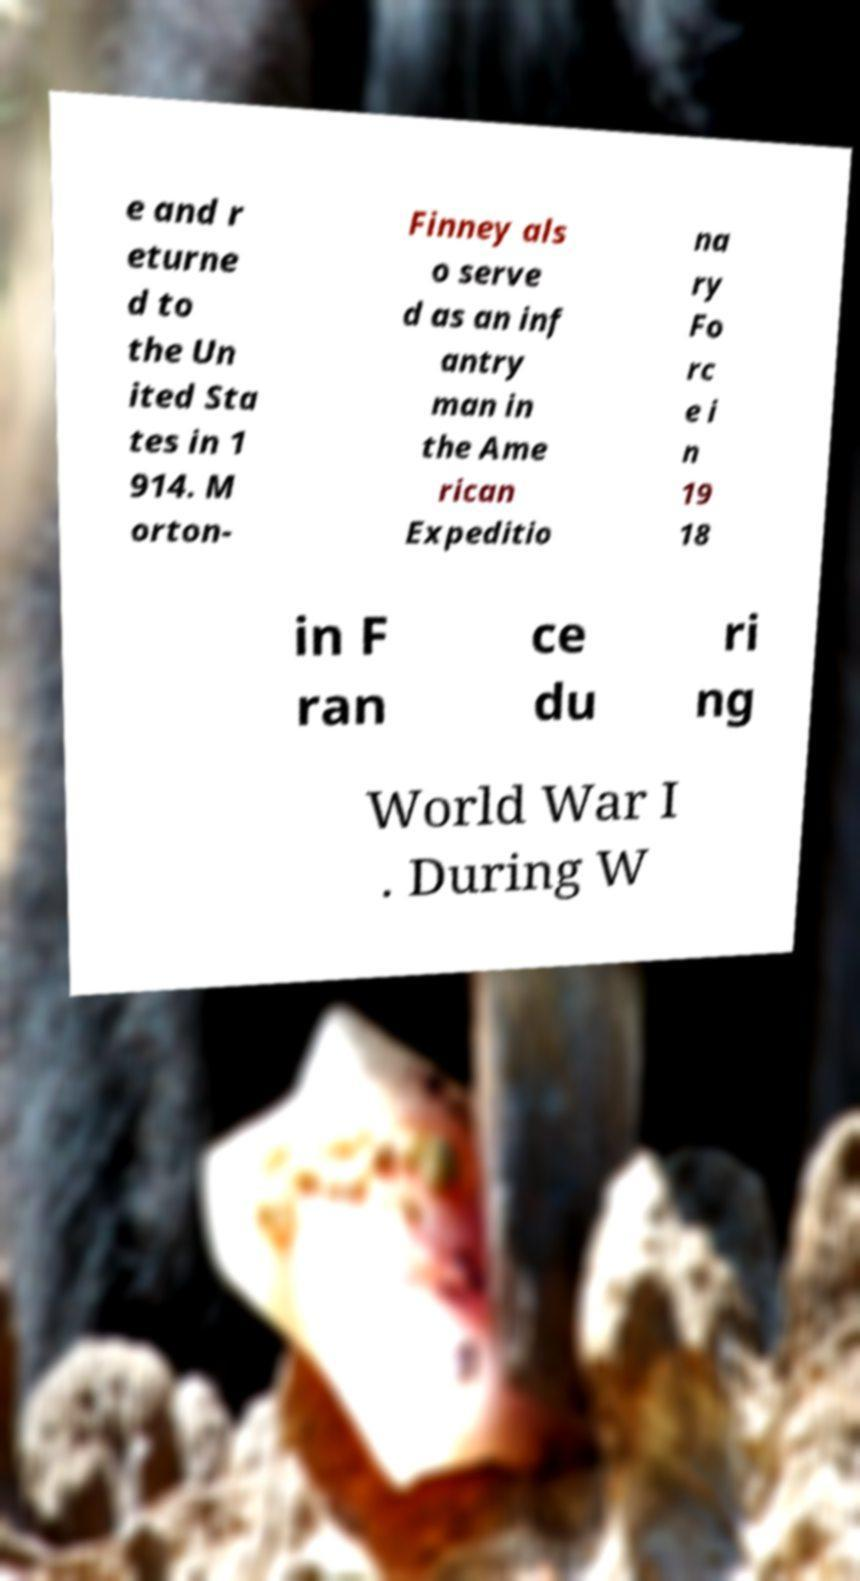What messages or text are displayed in this image? I need them in a readable, typed format. e and r eturne d to the Un ited Sta tes in 1 914. M orton- Finney als o serve d as an inf antry man in the Ame rican Expeditio na ry Fo rc e i n 19 18 in F ran ce du ri ng World War I . During W 